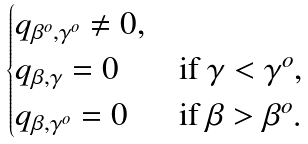<formula> <loc_0><loc_0><loc_500><loc_500>\begin{cases} q _ { \beta ^ { o } , \gamma ^ { o } } \ne 0 , \\ q _ { \beta , \gamma } = 0 & \text {if } \gamma < \gamma ^ { o } , \\ q _ { \beta , \gamma ^ { o } } = 0 & \text {if } \beta > \beta ^ { o } . \end{cases}</formula> 